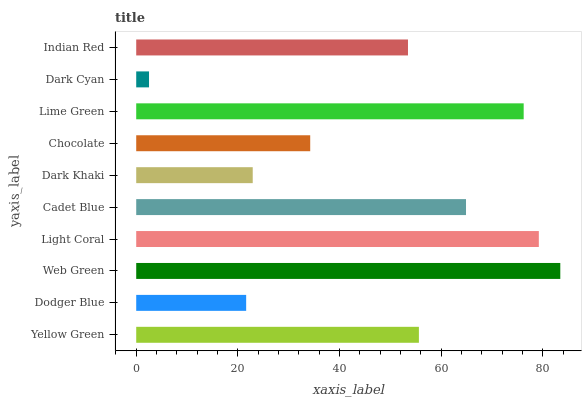Is Dark Cyan the minimum?
Answer yes or no. Yes. Is Web Green the maximum?
Answer yes or no. Yes. Is Dodger Blue the minimum?
Answer yes or no. No. Is Dodger Blue the maximum?
Answer yes or no. No. Is Yellow Green greater than Dodger Blue?
Answer yes or no. Yes. Is Dodger Blue less than Yellow Green?
Answer yes or no. Yes. Is Dodger Blue greater than Yellow Green?
Answer yes or no. No. Is Yellow Green less than Dodger Blue?
Answer yes or no. No. Is Yellow Green the high median?
Answer yes or no. Yes. Is Indian Red the low median?
Answer yes or no. Yes. Is Dodger Blue the high median?
Answer yes or no. No. Is Dodger Blue the low median?
Answer yes or no. No. 